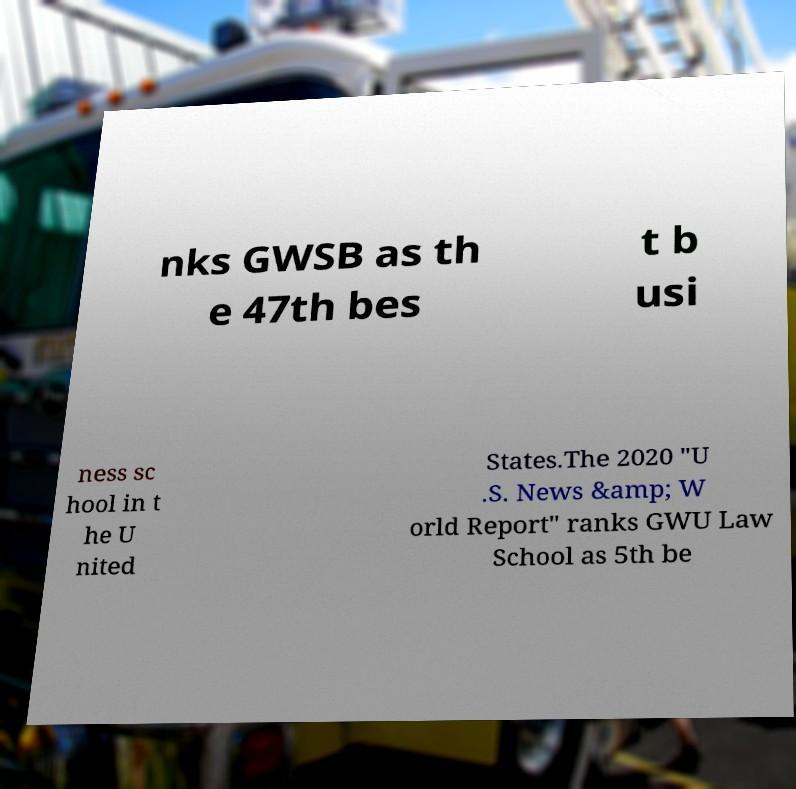Could you assist in decoding the text presented in this image and type it out clearly? nks GWSB as th e 47th bes t b usi ness sc hool in t he U nited States.The 2020 "U .S. News &amp; W orld Report" ranks GWU Law School as 5th be 